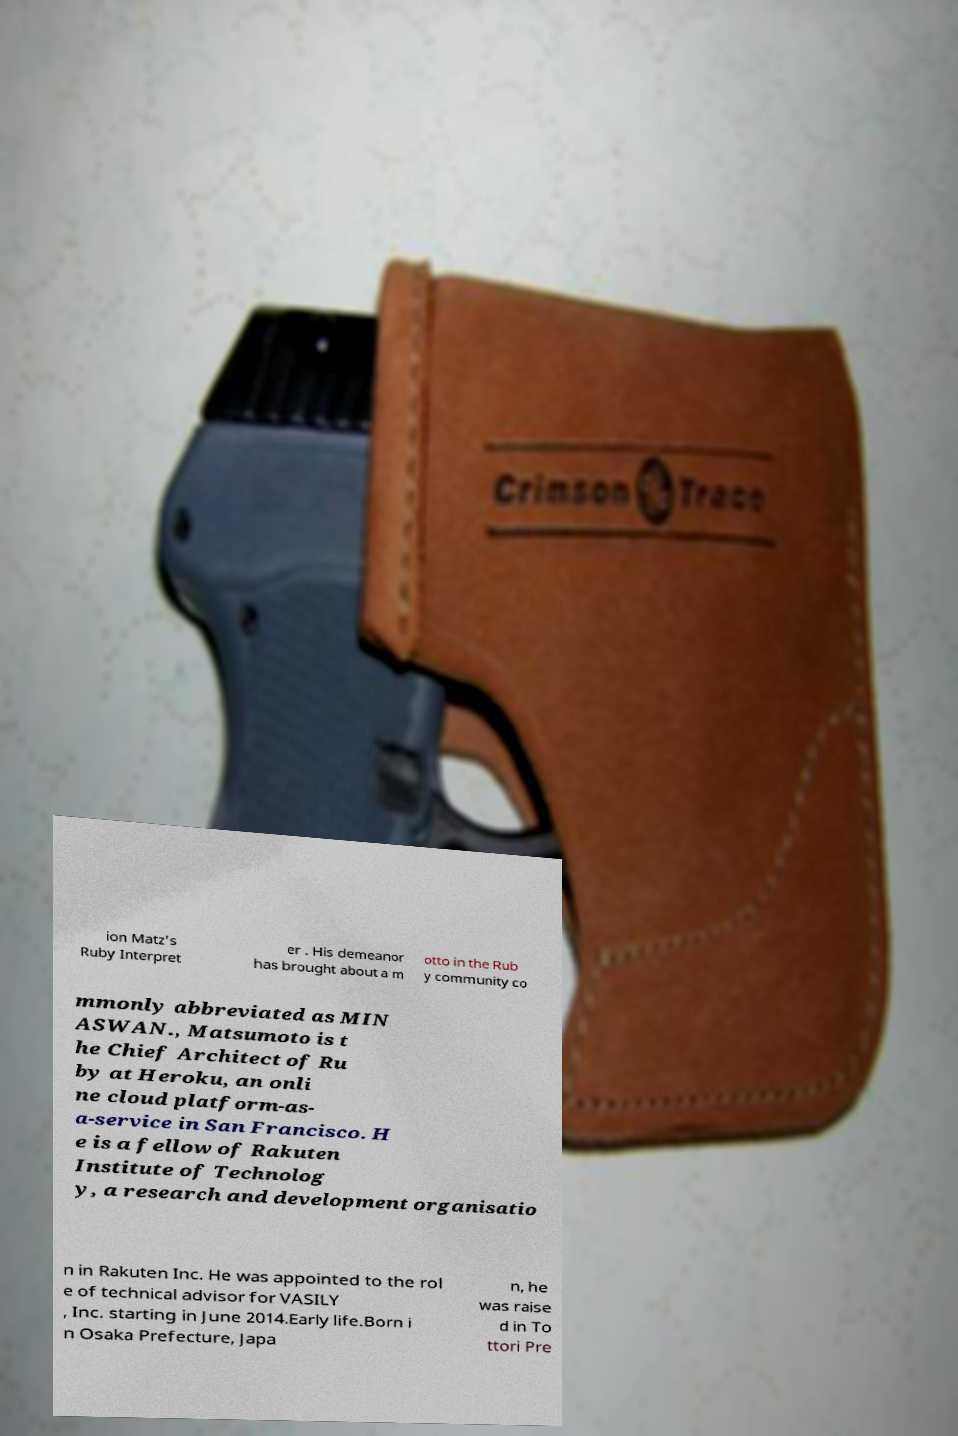For documentation purposes, I need the text within this image transcribed. Could you provide that? ion Matz's Ruby Interpret er . His demeanor has brought about a m otto in the Rub y community co mmonly abbreviated as MIN ASWAN., Matsumoto is t he Chief Architect of Ru by at Heroku, an onli ne cloud platform-as- a-service in San Francisco. H e is a fellow of Rakuten Institute of Technolog y, a research and development organisatio n in Rakuten Inc. He was appointed to the rol e of technical advisor for VASILY , Inc. starting in June 2014.Early life.Born i n Osaka Prefecture, Japa n, he was raise d in To ttori Pre 